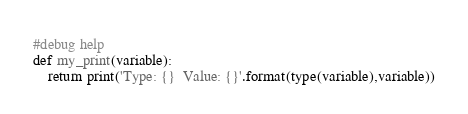<code> <loc_0><loc_0><loc_500><loc_500><_Python_>#debug help
def my_print(variable):
    return print('Type: {}  Value: {}'.format(type(variable),variable))</code> 